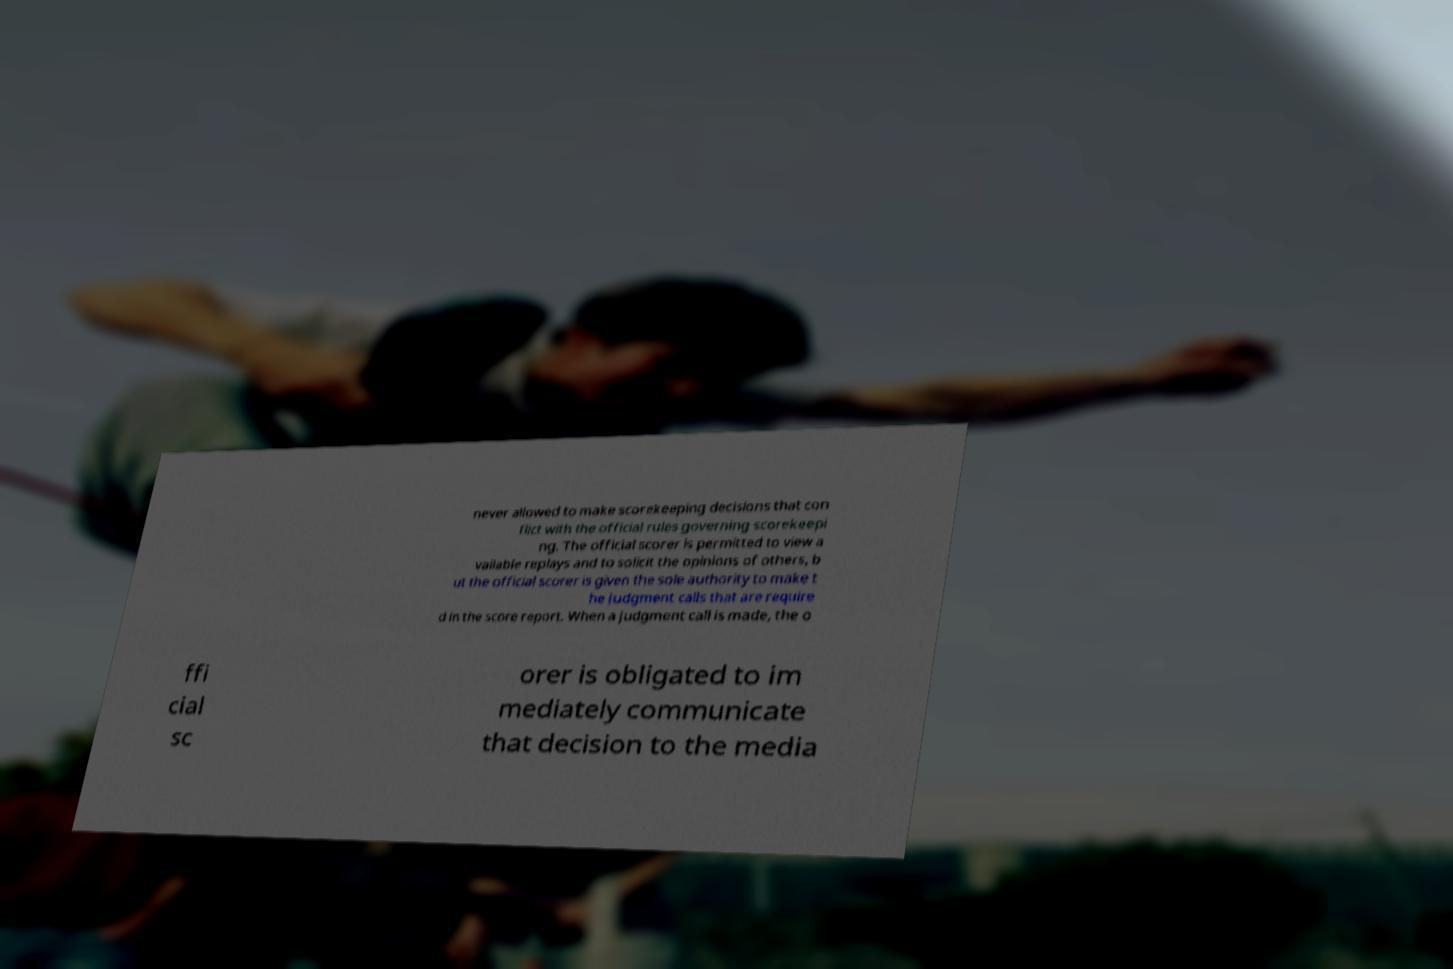Can you accurately transcribe the text from the provided image for me? never allowed to make scorekeeping decisions that con flict with the official rules governing scorekeepi ng. The official scorer is permitted to view a vailable replays and to solicit the opinions of others, b ut the official scorer is given the sole authority to make t he judgment calls that are require d in the score report. When a judgment call is made, the o ffi cial sc orer is obligated to im mediately communicate that decision to the media 